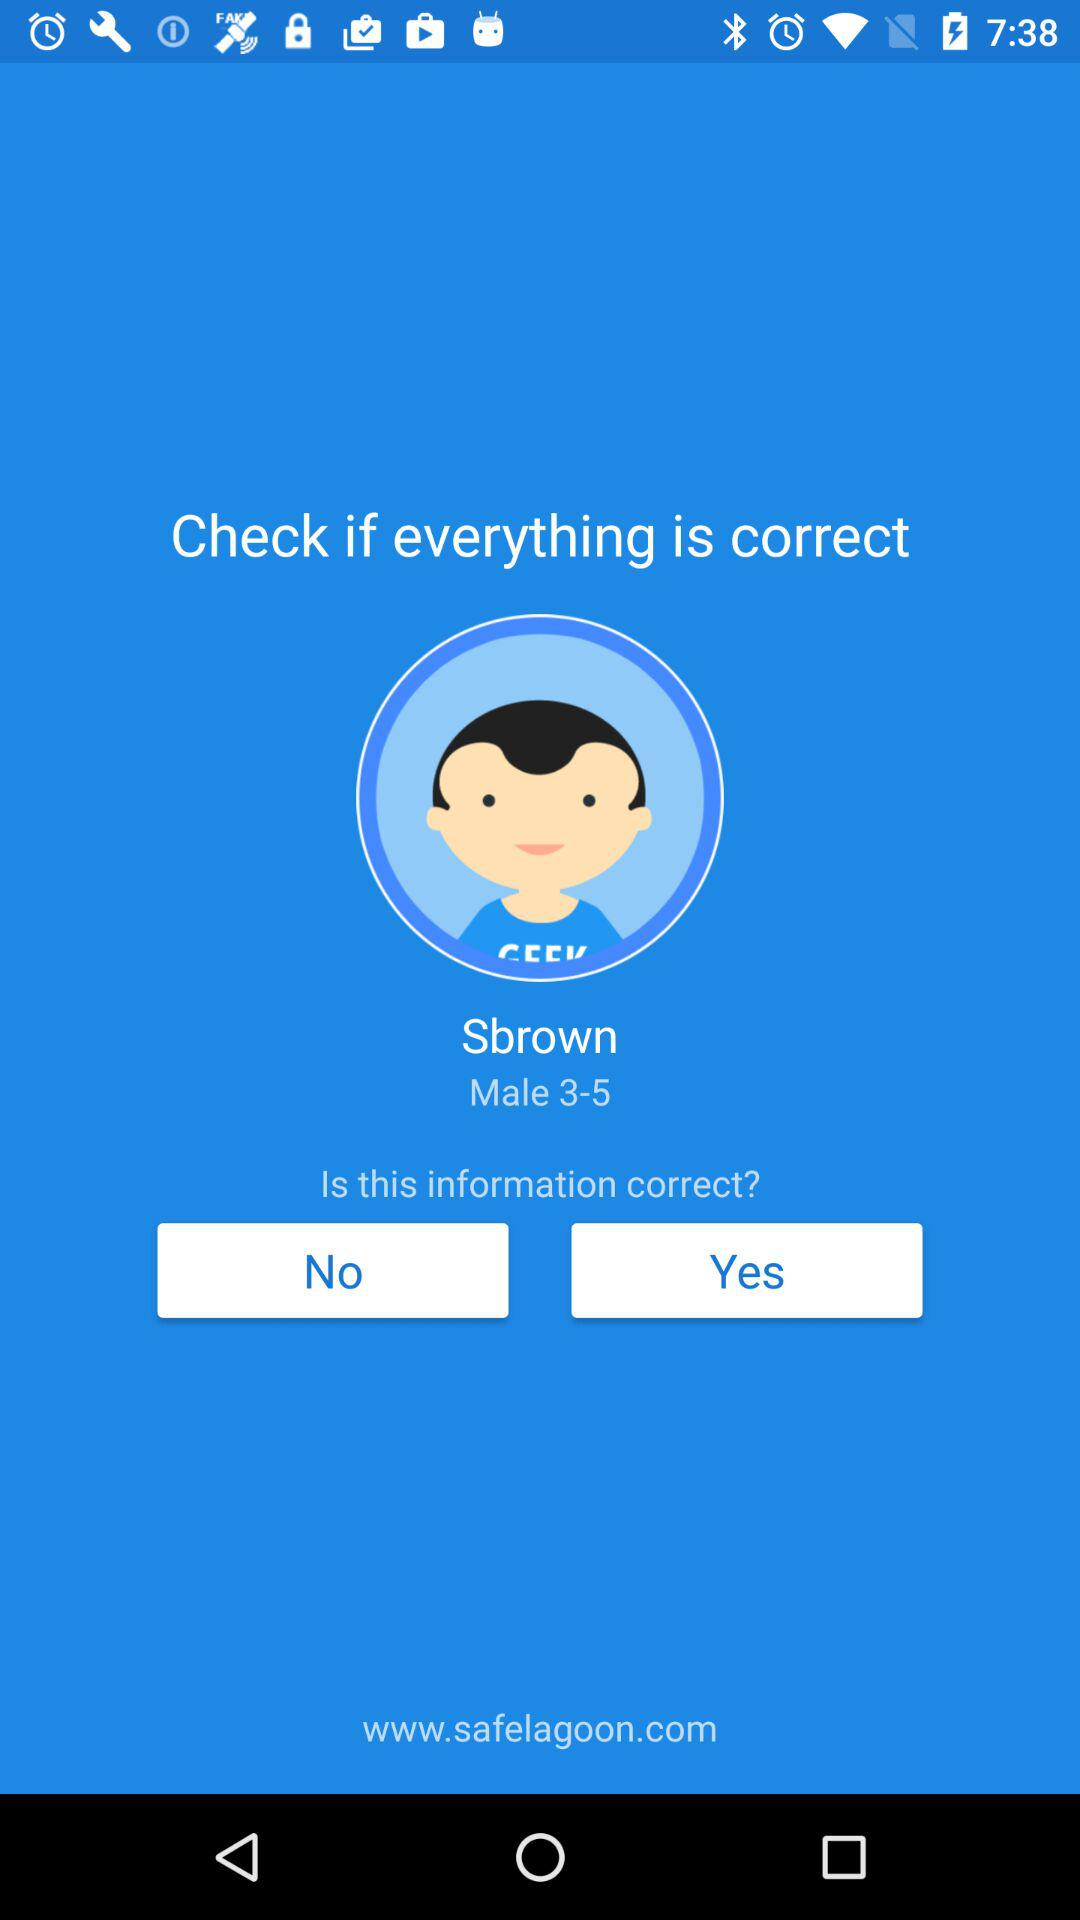What is the age group? The age group is 3 to 5 years. 